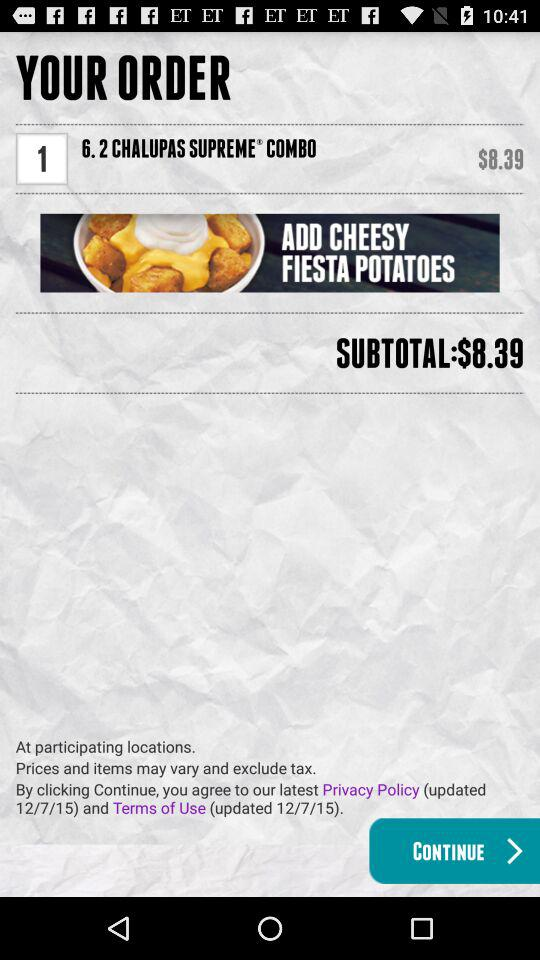When were the latest "Privacy Policy" and "Terms of Use" updated? The latest "Privacy Policy" and "Terms of Use" were updated on 12/7/15. 